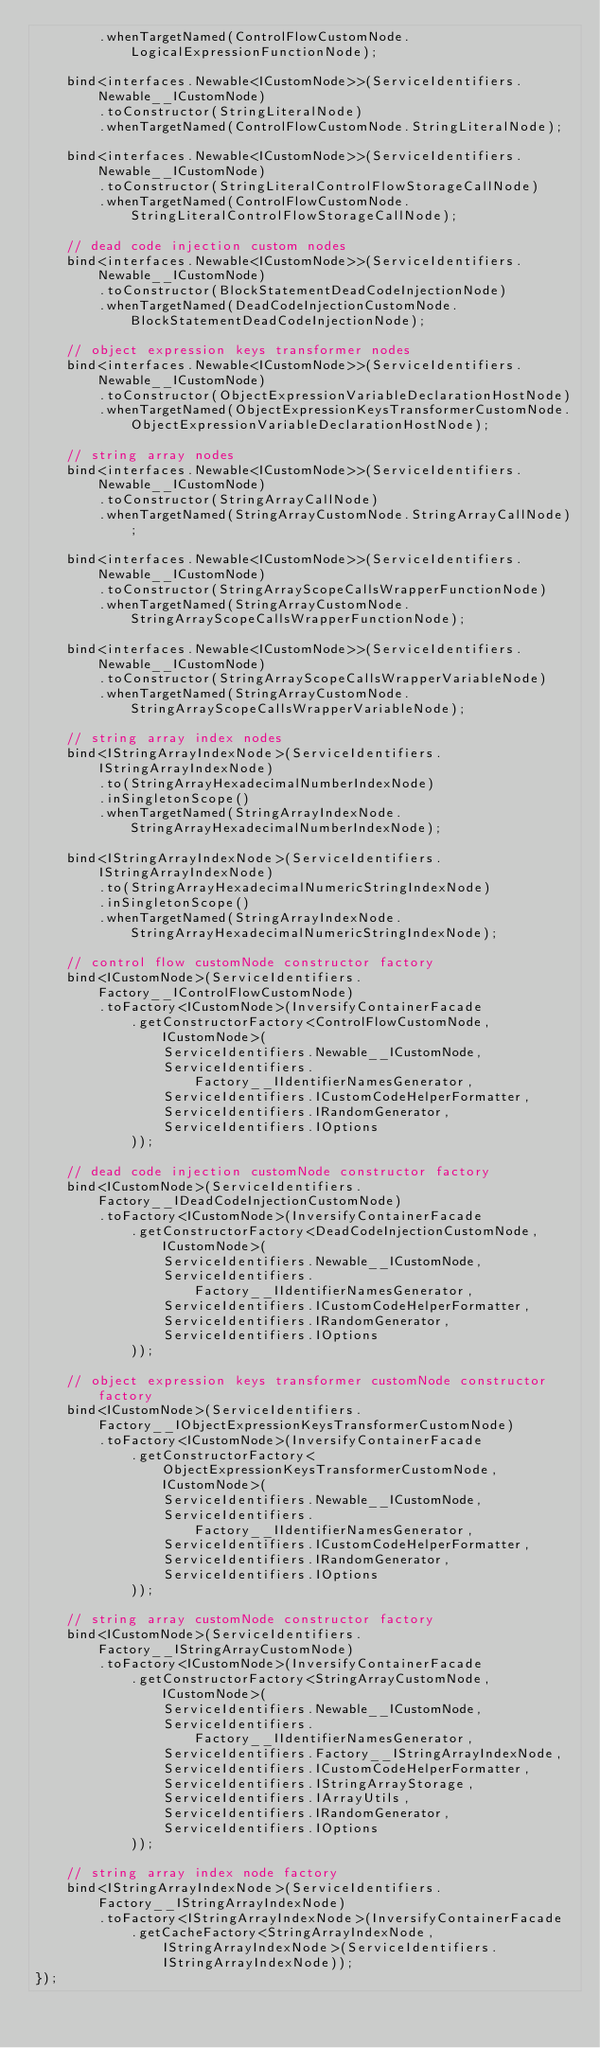Convert code to text. <code><loc_0><loc_0><loc_500><loc_500><_TypeScript_>        .whenTargetNamed(ControlFlowCustomNode.LogicalExpressionFunctionNode);

    bind<interfaces.Newable<ICustomNode>>(ServiceIdentifiers.Newable__ICustomNode)
        .toConstructor(StringLiteralNode)
        .whenTargetNamed(ControlFlowCustomNode.StringLiteralNode);

    bind<interfaces.Newable<ICustomNode>>(ServiceIdentifiers.Newable__ICustomNode)
        .toConstructor(StringLiteralControlFlowStorageCallNode)
        .whenTargetNamed(ControlFlowCustomNode.StringLiteralControlFlowStorageCallNode);

    // dead code injection custom nodes
    bind<interfaces.Newable<ICustomNode>>(ServiceIdentifiers.Newable__ICustomNode)
        .toConstructor(BlockStatementDeadCodeInjectionNode)
        .whenTargetNamed(DeadCodeInjectionCustomNode.BlockStatementDeadCodeInjectionNode);

    // object expression keys transformer nodes
    bind<interfaces.Newable<ICustomNode>>(ServiceIdentifiers.Newable__ICustomNode)
        .toConstructor(ObjectExpressionVariableDeclarationHostNode)
        .whenTargetNamed(ObjectExpressionKeysTransformerCustomNode.ObjectExpressionVariableDeclarationHostNode);

    // string array nodes
    bind<interfaces.Newable<ICustomNode>>(ServiceIdentifiers.Newable__ICustomNode)
        .toConstructor(StringArrayCallNode)
        .whenTargetNamed(StringArrayCustomNode.StringArrayCallNode);

    bind<interfaces.Newable<ICustomNode>>(ServiceIdentifiers.Newable__ICustomNode)
        .toConstructor(StringArrayScopeCallsWrapperFunctionNode)
        .whenTargetNamed(StringArrayCustomNode.StringArrayScopeCallsWrapperFunctionNode);

    bind<interfaces.Newable<ICustomNode>>(ServiceIdentifiers.Newable__ICustomNode)
        .toConstructor(StringArrayScopeCallsWrapperVariableNode)
        .whenTargetNamed(StringArrayCustomNode.StringArrayScopeCallsWrapperVariableNode);

    // string array index nodes
    bind<IStringArrayIndexNode>(ServiceIdentifiers.IStringArrayIndexNode)
        .to(StringArrayHexadecimalNumberIndexNode)
        .inSingletonScope()
        .whenTargetNamed(StringArrayIndexNode.StringArrayHexadecimalNumberIndexNode);

    bind<IStringArrayIndexNode>(ServiceIdentifiers.IStringArrayIndexNode)
        .to(StringArrayHexadecimalNumericStringIndexNode)
        .inSingletonScope()
        .whenTargetNamed(StringArrayIndexNode.StringArrayHexadecimalNumericStringIndexNode);

    // control flow customNode constructor factory
    bind<ICustomNode>(ServiceIdentifiers.Factory__IControlFlowCustomNode)
        .toFactory<ICustomNode>(InversifyContainerFacade
            .getConstructorFactory<ControlFlowCustomNode, ICustomNode>(
                ServiceIdentifiers.Newable__ICustomNode,
                ServiceIdentifiers.Factory__IIdentifierNamesGenerator,
                ServiceIdentifiers.ICustomCodeHelperFormatter,
                ServiceIdentifiers.IRandomGenerator,
                ServiceIdentifiers.IOptions
            ));

    // dead code injection customNode constructor factory
    bind<ICustomNode>(ServiceIdentifiers.Factory__IDeadCodeInjectionCustomNode)
        .toFactory<ICustomNode>(InversifyContainerFacade
            .getConstructorFactory<DeadCodeInjectionCustomNode, ICustomNode>(
                ServiceIdentifiers.Newable__ICustomNode,
                ServiceIdentifiers.Factory__IIdentifierNamesGenerator,
                ServiceIdentifiers.ICustomCodeHelperFormatter,
                ServiceIdentifiers.IRandomGenerator,
                ServiceIdentifiers.IOptions
            ));

    // object expression keys transformer customNode constructor factory
    bind<ICustomNode>(ServiceIdentifiers.Factory__IObjectExpressionKeysTransformerCustomNode)
        .toFactory<ICustomNode>(InversifyContainerFacade
            .getConstructorFactory<ObjectExpressionKeysTransformerCustomNode, ICustomNode>(
                ServiceIdentifiers.Newable__ICustomNode,
                ServiceIdentifiers.Factory__IIdentifierNamesGenerator,
                ServiceIdentifiers.ICustomCodeHelperFormatter,
                ServiceIdentifiers.IRandomGenerator,
                ServiceIdentifiers.IOptions
            ));

    // string array customNode constructor factory
    bind<ICustomNode>(ServiceIdentifiers.Factory__IStringArrayCustomNode)
        .toFactory<ICustomNode>(InversifyContainerFacade
            .getConstructorFactory<StringArrayCustomNode, ICustomNode>(
                ServiceIdentifiers.Newable__ICustomNode,
                ServiceIdentifiers.Factory__IIdentifierNamesGenerator,
                ServiceIdentifiers.Factory__IStringArrayIndexNode,
                ServiceIdentifiers.ICustomCodeHelperFormatter,
                ServiceIdentifiers.IStringArrayStorage,
                ServiceIdentifiers.IArrayUtils,
                ServiceIdentifiers.IRandomGenerator,
                ServiceIdentifiers.IOptions
            ));

    // string array index node factory
    bind<IStringArrayIndexNode>(ServiceIdentifiers.Factory__IStringArrayIndexNode)
        .toFactory<IStringArrayIndexNode>(InversifyContainerFacade
            .getCacheFactory<StringArrayIndexNode, IStringArrayIndexNode>(ServiceIdentifiers.IStringArrayIndexNode));
});
</code> 